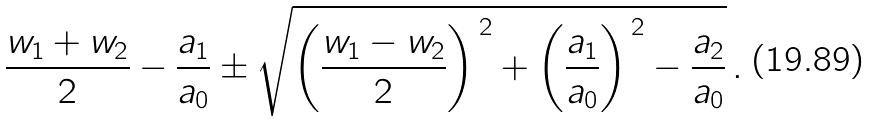Convert formula to latex. <formula><loc_0><loc_0><loc_500><loc_500>\frac { w _ { 1 } + w _ { 2 } } { 2 } - \frac { a _ { 1 } } { a _ { 0 } } \pm \sqrt { \left ( \frac { w _ { 1 } - w _ { 2 } } { 2 } \right ) ^ { \, 2 } + \left ( \frac { a _ { 1 } } { a _ { 0 } } \right ) ^ { \, 2 } - \frac { a _ { 2 } } { a _ { 0 } } } \, .</formula> 